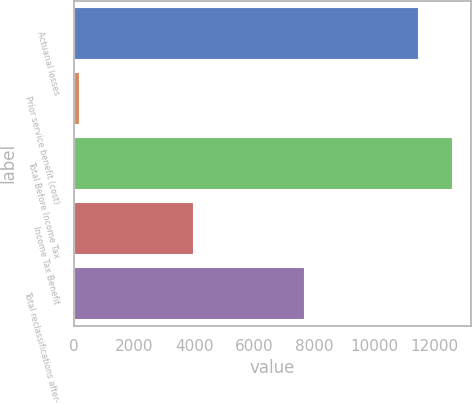Convert chart. <chart><loc_0><loc_0><loc_500><loc_500><bar_chart><fcel>Actuarial losses<fcel>Prior service benefit (cost)<fcel>Total Before Income Tax<fcel>Income Tax Benefit<fcel>Total reclassifications after-<nl><fcel>11444<fcel>152<fcel>12588.4<fcel>3955<fcel>7641<nl></chart> 